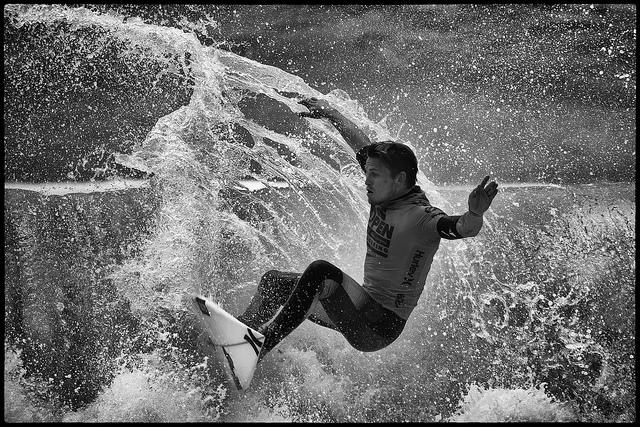Did the water just push the surfer?
Quick response, please. Yes. What are the odds the surfer will fall?
Short answer required. High. What gender is the surfer?
Quick response, please. Male. 